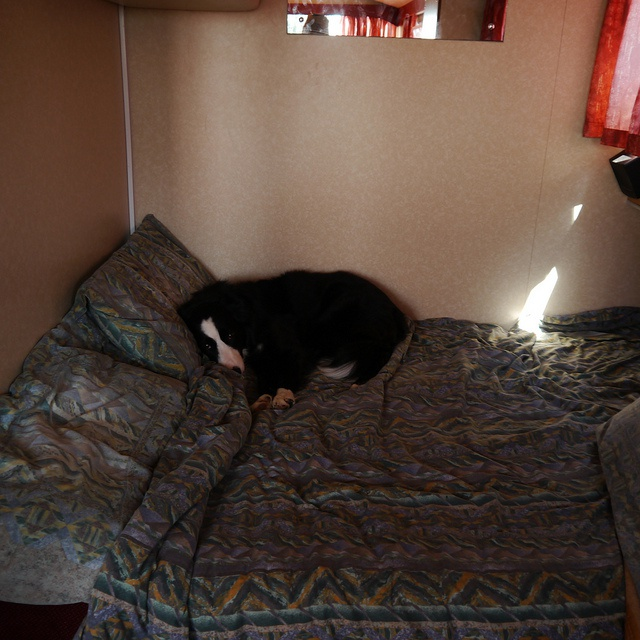Describe the objects in this image and their specific colors. I can see bed in maroon, black, and gray tones and dog in maroon, black, and gray tones in this image. 